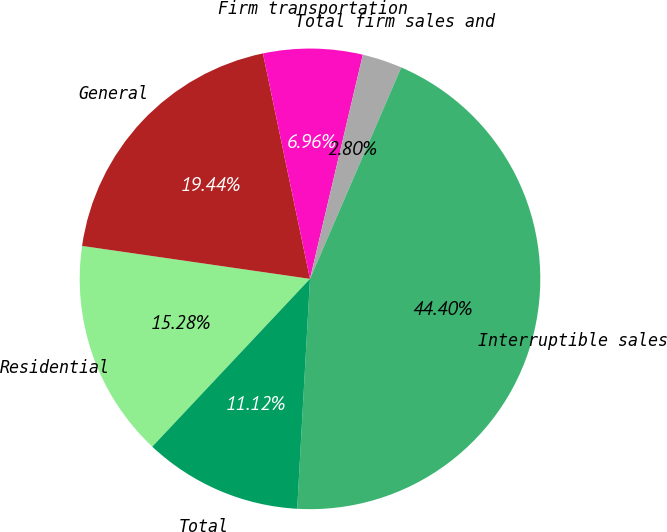<chart> <loc_0><loc_0><loc_500><loc_500><pie_chart><fcel>Residential<fcel>General<fcel>Firm transportation<fcel>Total firm sales and<fcel>Interruptible sales<fcel>Total<nl><fcel>15.28%<fcel>19.44%<fcel>6.96%<fcel>2.8%<fcel>44.4%<fcel>11.12%<nl></chart> 